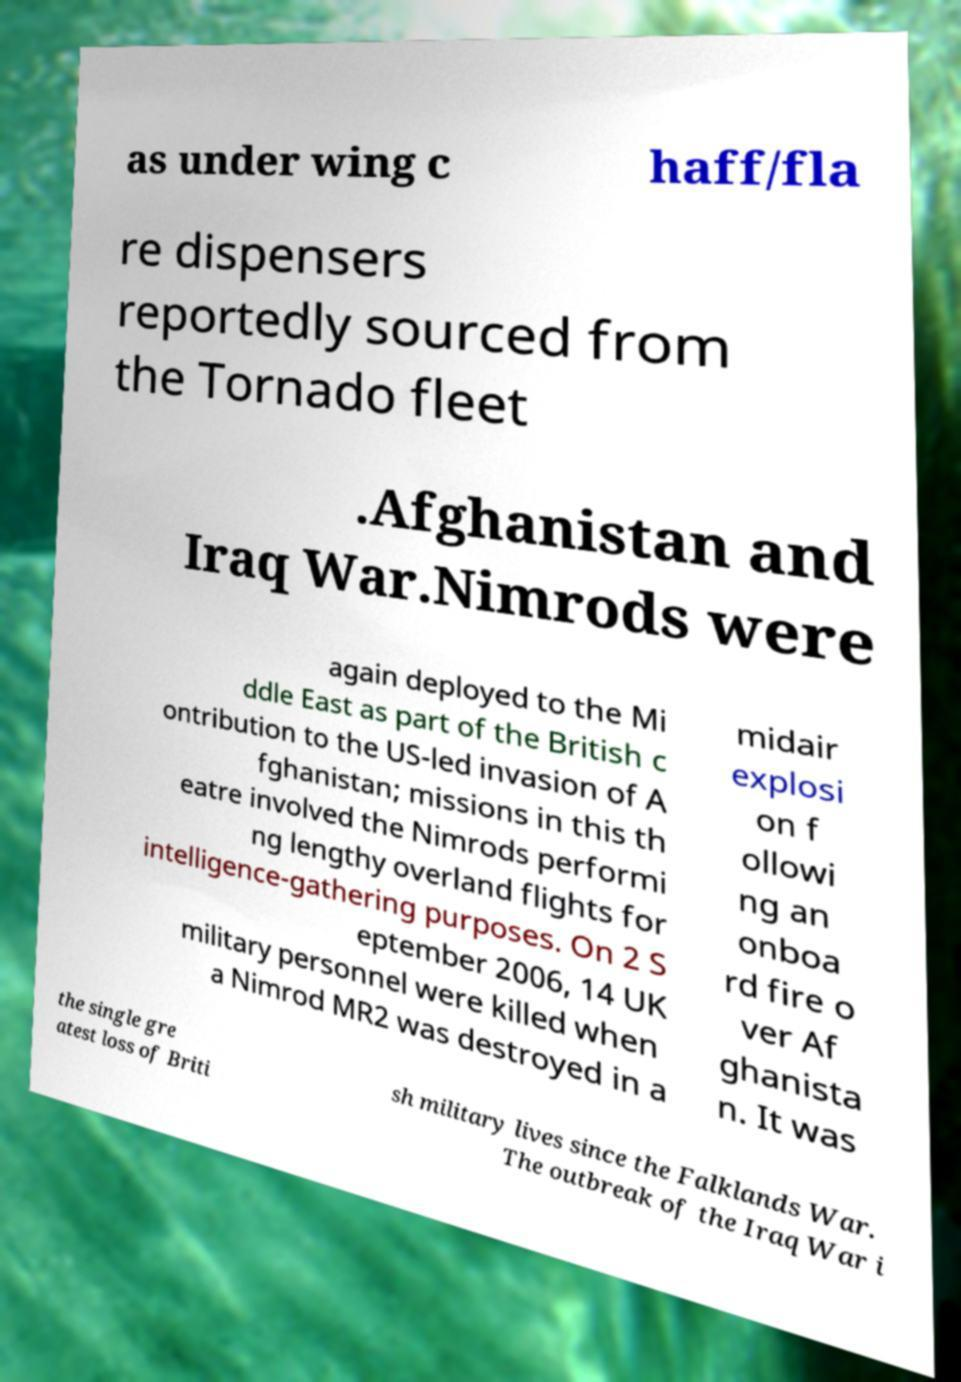Could you assist in decoding the text presented in this image and type it out clearly? as under wing c haff/fla re dispensers reportedly sourced from the Tornado fleet .Afghanistan and Iraq War.Nimrods were again deployed to the Mi ddle East as part of the British c ontribution to the US-led invasion of A fghanistan; missions in this th eatre involved the Nimrods performi ng lengthy overland flights for intelligence-gathering purposes. On 2 S eptember 2006, 14 UK military personnel were killed when a Nimrod MR2 was destroyed in a midair explosi on f ollowi ng an onboa rd fire o ver Af ghanista n. It was the single gre atest loss of Briti sh military lives since the Falklands War. The outbreak of the Iraq War i 